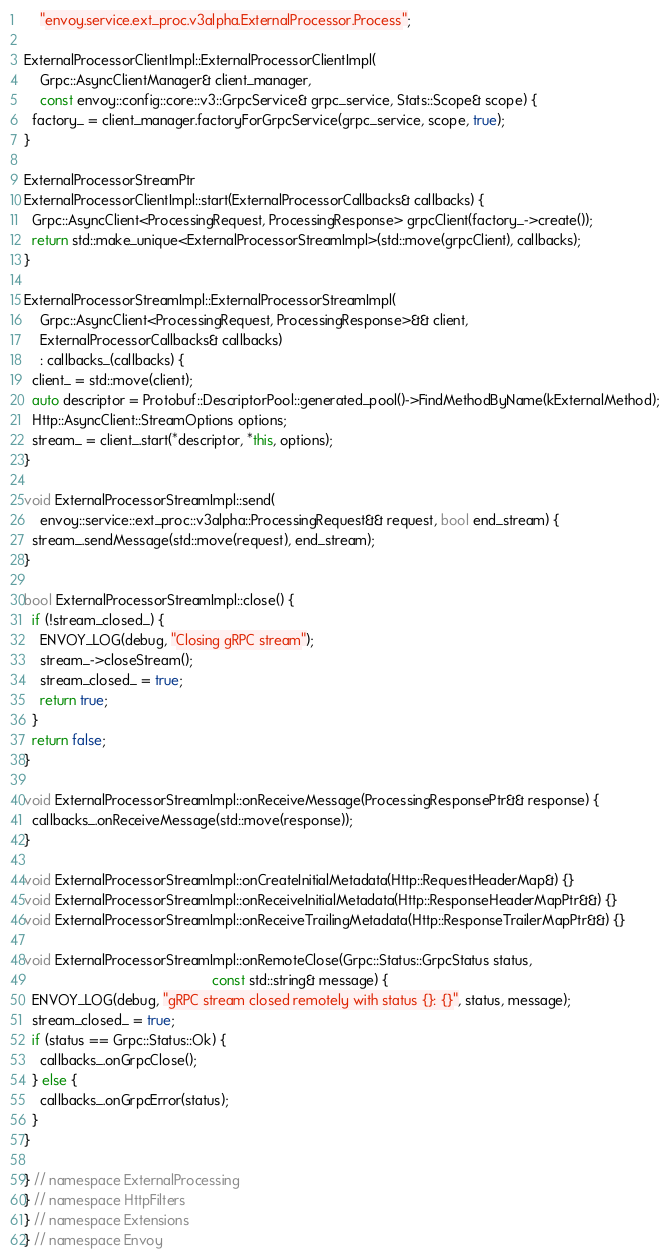<code> <loc_0><loc_0><loc_500><loc_500><_C++_>    "envoy.service.ext_proc.v3alpha.ExternalProcessor.Process";

ExternalProcessorClientImpl::ExternalProcessorClientImpl(
    Grpc::AsyncClientManager& client_manager,
    const envoy::config::core::v3::GrpcService& grpc_service, Stats::Scope& scope) {
  factory_ = client_manager.factoryForGrpcService(grpc_service, scope, true);
}

ExternalProcessorStreamPtr
ExternalProcessorClientImpl::start(ExternalProcessorCallbacks& callbacks) {
  Grpc::AsyncClient<ProcessingRequest, ProcessingResponse> grpcClient(factory_->create());
  return std::make_unique<ExternalProcessorStreamImpl>(std::move(grpcClient), callbacks);
}

ExternalProcessorStreamImpl::ExternalProcessorStreamImpl(
    Grpc::AsyncClient<ProcessingRequest, ProcessingResponse>&& client,
    ExternalProcessorCallbacks& callbacks)
    : callbacks_(callbacks) {
  client_ = std::move(client);
  auto descriptor = Protobuf::DescriptorPool::generated_pool()->FindMethodByName(kExternalMethod);
  Http::AsyncClient::StreamOptions options;
  stream_ = client_.start(*descriptor, *this, options);
}

void ExternalProcessorStreamImpl::send(
    envoy::service::ext_proc::v3alpha::ProcessingRequest&& request, bool end_stream) {
  stream_.sendMessage(std::move(request), end_stream);
}

bool ExternalProcessorStreamImpl::close() {
  if (!stream_closed_) {
    ENVOY_LOG(debug, "Closing gRPC stream");
    stream_->closeStream();
    stream_closed_ = true;
    return true;
  }
  return false;
}

void ExternalProcessorStreamImpl::onReceiveMessage(ProcessingResponsePtr&& response) {
  callbacks_.onReceiveMessage(std::move(response));
}

void ExternalProcessorStreamImpl::onCreateInitialMetadata(Http::RequestHeaderMap&) {}
void ExternalProcessorStreamImpl::onReceiveInitialMetadata(Http::ResponseHeaderMapPtr&&) {}
void ExternalProcessorStreamImpl::onReceiveTrailingMetadata(Http::ResponseTrailerMapPtr&&) {}

void ExternalProcessorStreamImpl::onRemoteClose(Grpc::Status::GrpcStatus status,
                                                const std::string& message) {
  ENVOY_LOG(debug, "gRPC stream closed remotely with status {}: {}", status, message);
  stream_closed_ = true;
  if (status == Grpc::Status::Ok) {
    callbacks_.onGrpcClose();
  } else {
    callbacks_.onGrpcError(status);
  }
}

} // namespace ExternalProcessing
} // namespace HttpFilters
} // namespace Extensions
} // namespace Envoy
</code> 